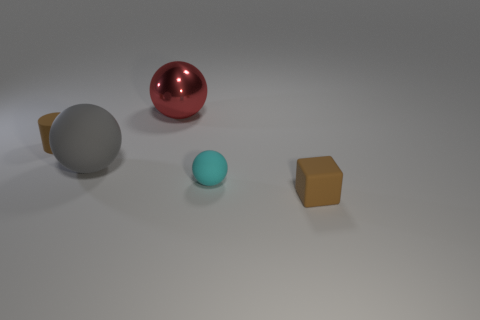Subtract all large gray rubber balls. How many balls are left? 2 Add 3 big gray balls. How many objects exist? 8 Subtract all balls. How many objects are left? 2 Add 2 gray spheres. How many gray spheres are left? 3 Add 2 green shiny balls. How many green shiny balls exist? 2 Subtract 0 brown spheres. How many objects are left? 5 Subtract all small green cubes. Subtract all red metallic spheres. How many objects are left? 4 